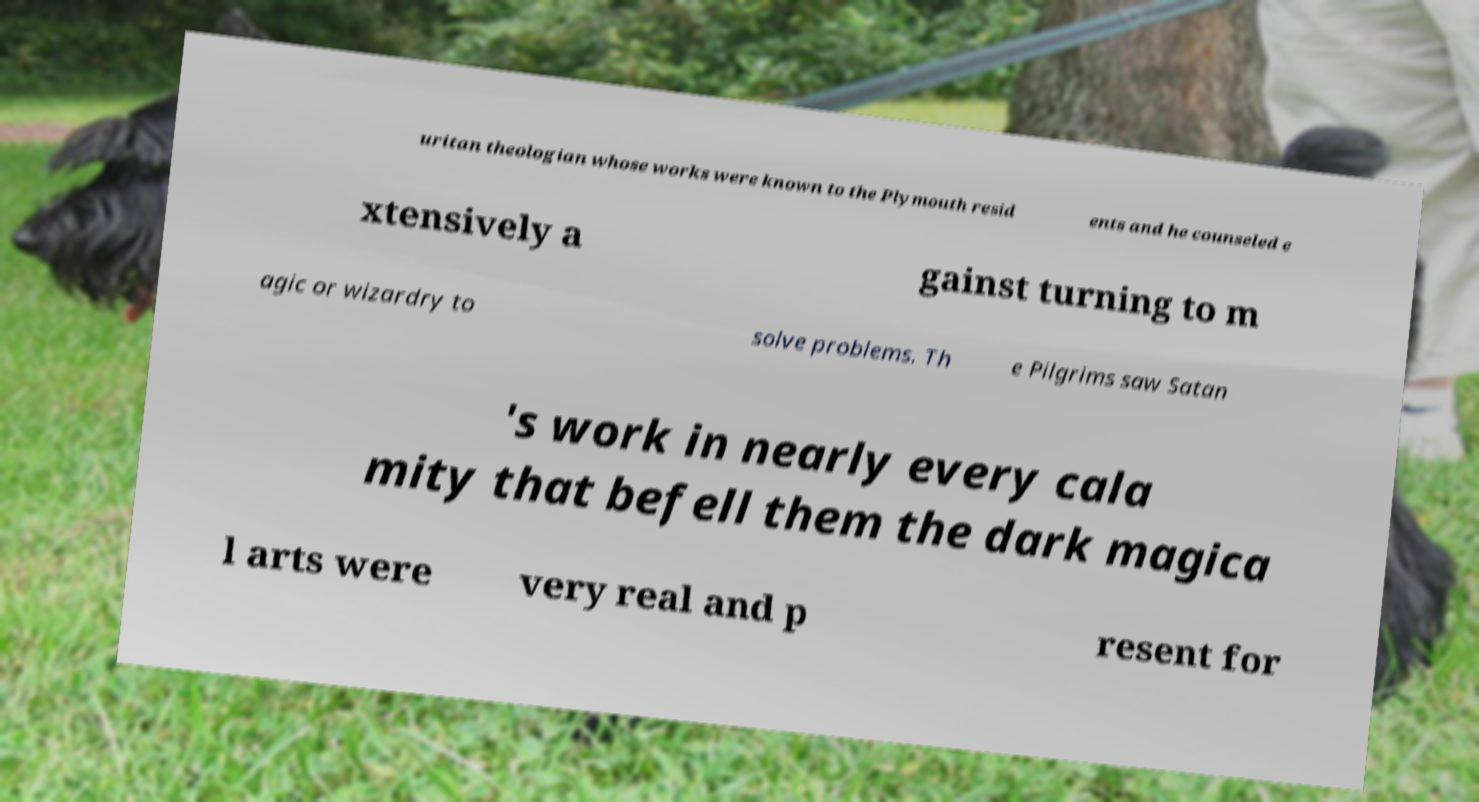Can you accurately transcribe the text from the provided image for me? uritan theologian whose works were known to the Plymouth resid ents and he counseled e xtensively a gainst turning to m agic or wizardry to solve problems. Th e Pilgrims saw Satan 's work in nearly every cala mity that befell them the dark magica l arts were very real and p resent for 